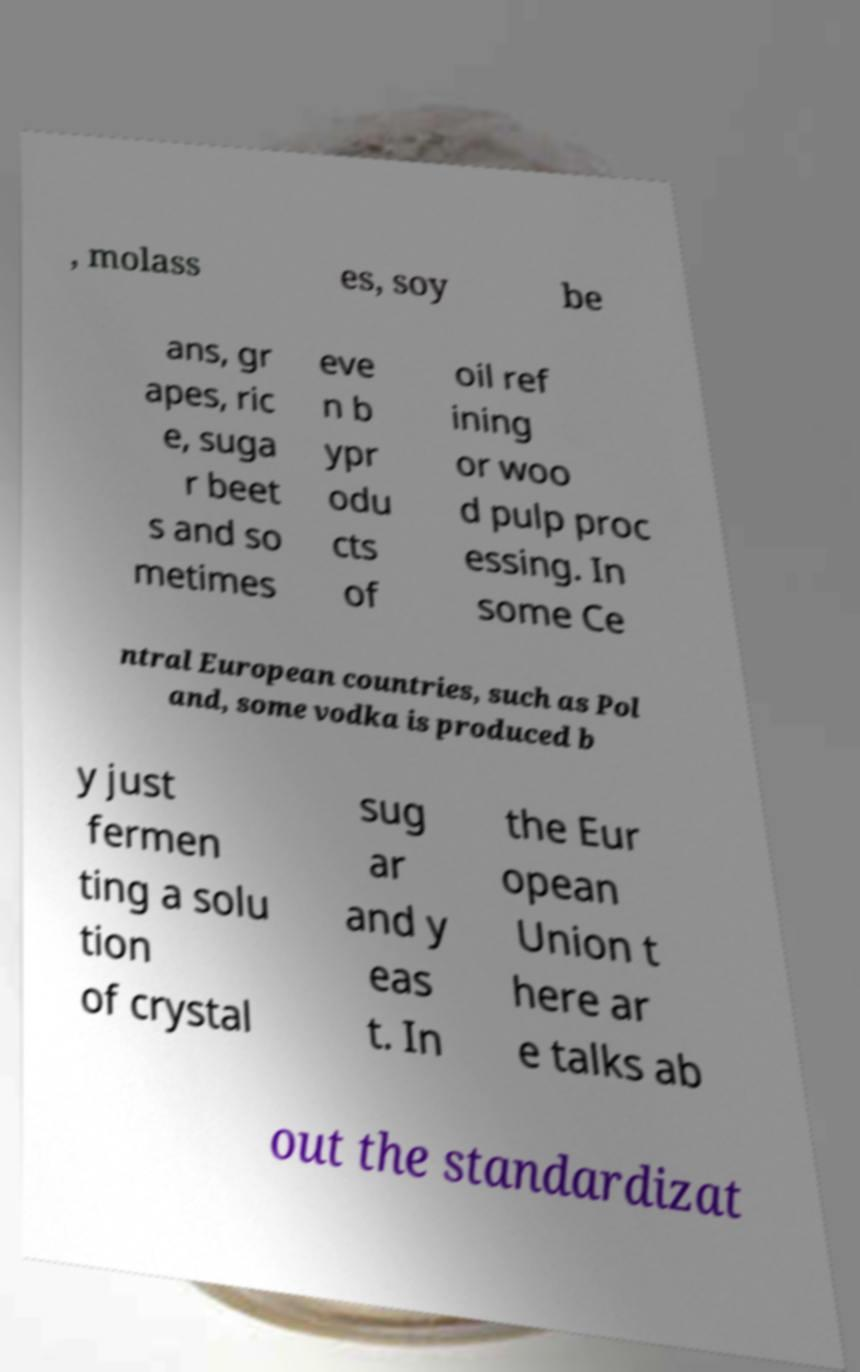Please read and relay the text visible in this image. What does it say? , molass es, soy be ans, gr apes, ric e, suga r beet s and so metimes eve n b ypr odu cts of oil ref ining or woo d pulp proc essing. In some Ce ntral European countries, such as Pol and, some vodka is produced b y just fermen ting a solu tion of crystal sug ar and y eas t. In the Eur opean Union t here ar e talks ab out the standardizat 